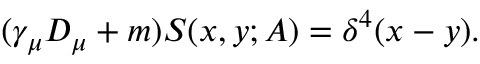Convert formula to latex. <formula><loc_0><loc_0><loc_500><loc_500>( \gamma _ { \mu } D _ { \mu } + m ) S ( x , y ; A ) = \delta ^ { 4 } ( x - y ) .</formula> 